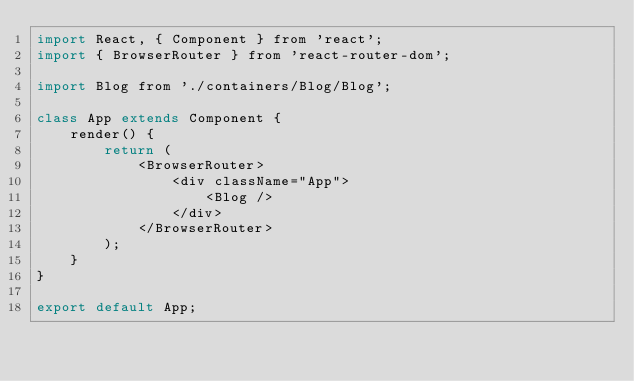<code> <loc_0><loc_0><loc_500><loc_500><_JavaScript_>import React, { Component } from 'react';
import { BrowserRouter } from 'react-router-dom';

import Blog from './containers/Blog/Blog';

class App extends Component {
    render() {
        return (
            <BrowserRouter>
                <div className="App">
                    <Blog />
                </div>
            </BrowserRouter>
        );
    }
}

export default App;
</code> 